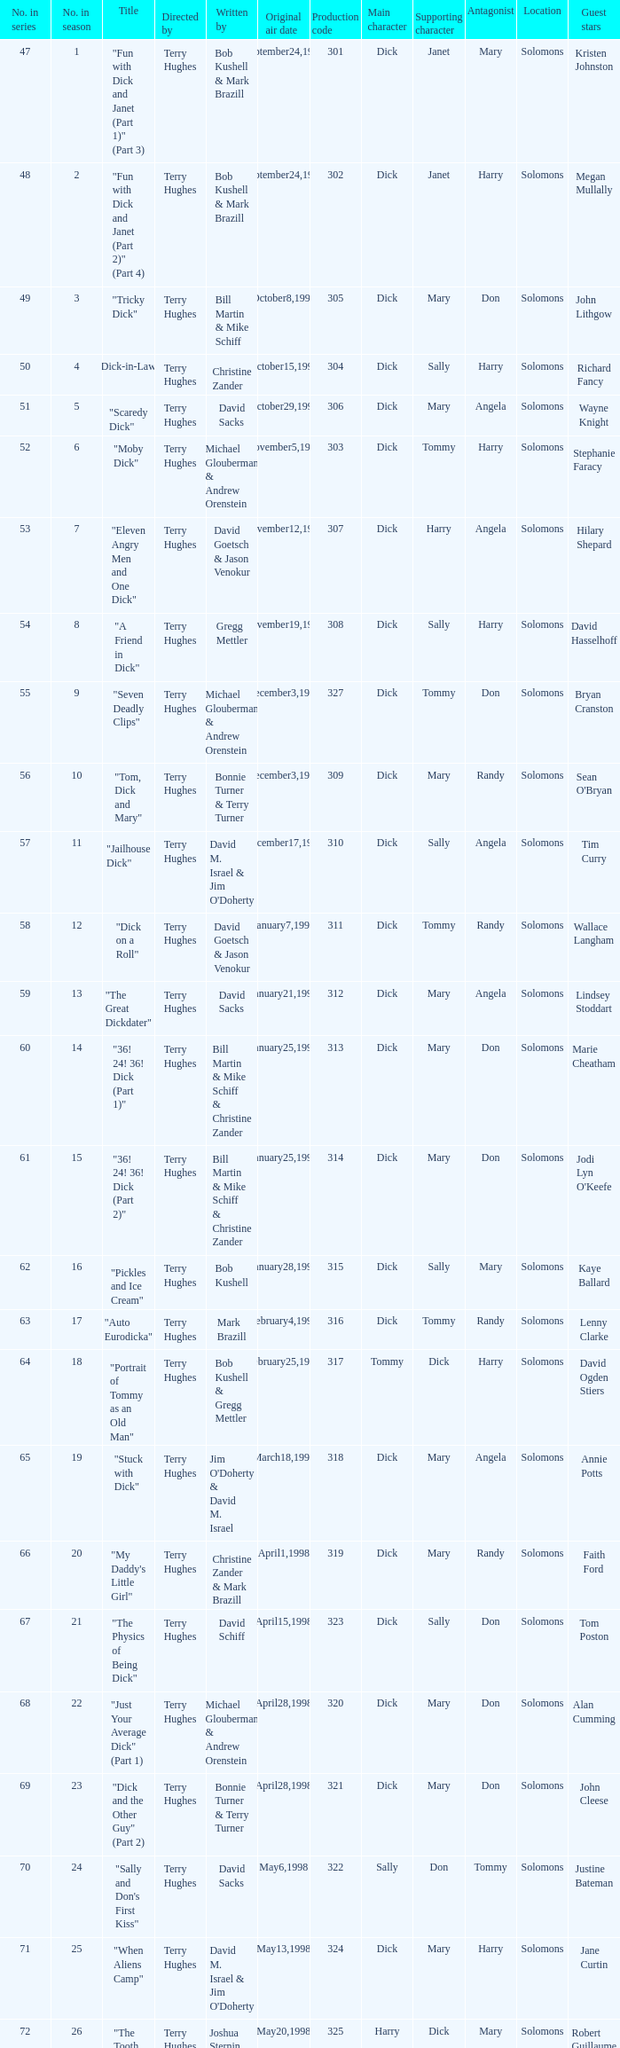Who were the writers of the episode titled "Tricky Dick"? Bill Martin & Mike Schiff. 